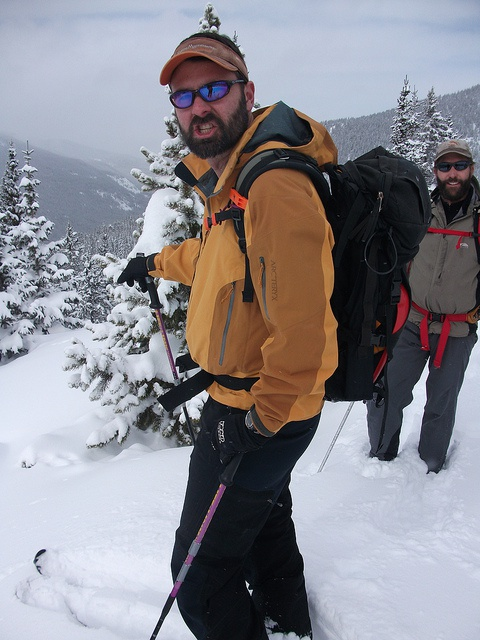Describe the objects in this image and their specific colors. I can see people in darkgray, black, brown, gray, and maroon tones, people in darkgray, black, gray, and maroon tones, backpack in darkgray, black, maroon, and gray tones, skis in darkgray, lavender, and lightgray tones, and backpack in darkgray, black, maroon, brown, and gray tones in this image. 